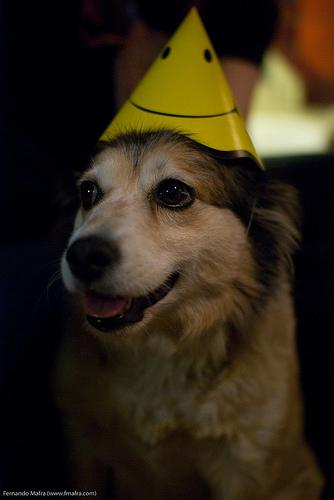Question: what animal is this?
Choices:
A. Cat.
B. Mouse.
C. Horse.
D. Dog.
Answer with the letter. Answer: D Question: what color are the dogs eyes?
Choices:
A. Green.
B. Blue.
C. Gray.
D. Black.
Answer with the letter. Answer: D Question: what design is on the party hat?
Choices:
A. Crying face.
B. Sad face.
C. Surprised face.
D. Smiley face.
Answer with the letter. Answer: D Question: what color is the party hat?
Choices:
A. Red.
B. Green.
C. Yellow.
D. Orange.
Answer with the letter. Answer: C Question: what is on the dog's head?
Choices:
A. Straw hat.
B. Party hat.
C. Baseball cap.
D. Tilley hat.
Answer with the letter. Answer: B 